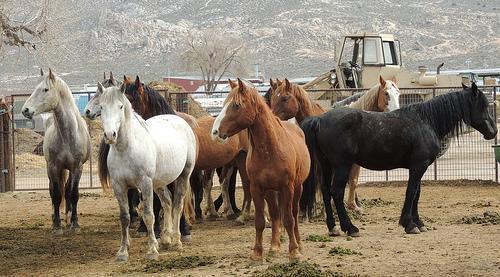How many black horses in corral?
Give a very brief answer. 1. How many black horses are visible?
Give a very brief answer. 1. How many brown horses have black manes?
Give a very brief answer. 1. How many black horses are facing to the right?
Give a very brief answer. 1. How many black horses are in the picture?
Give a very brief answer. 1. How many brown horses are there?
Give a very brief answer. 4. 